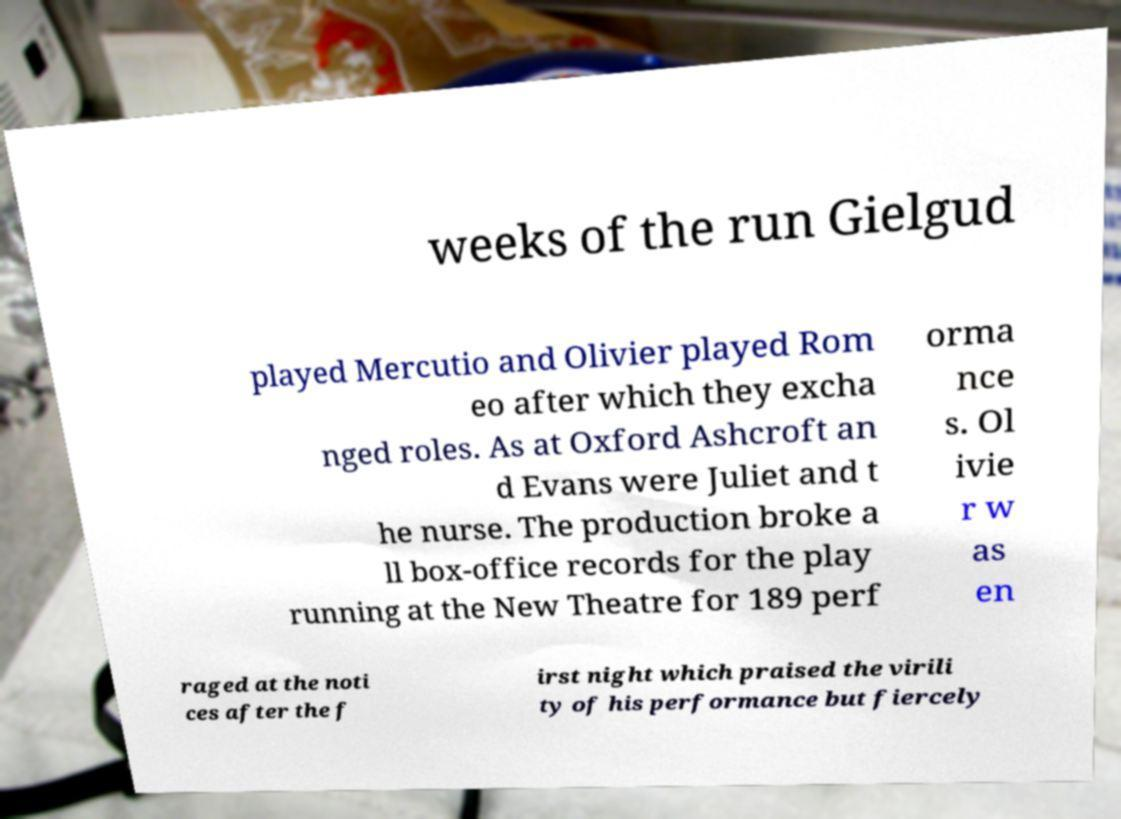Could you extract and type out the text from this image? weeks of the run Gielgud played Mercutio and Olivier played Rom eo after which they excha nged roles. As at Oxford Ashcroft an d Evans were Juliet and t he nurse. The production broke a ll box-office records for the play running at the New Theatre for 189 perf orma nce s. Ol ivie r w as en raged at the noti ces after the f irst night which praised the virili ty of his performance but fiercely 